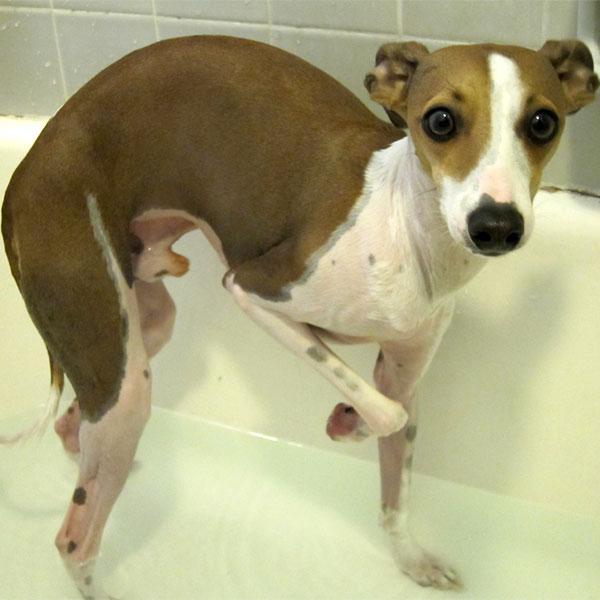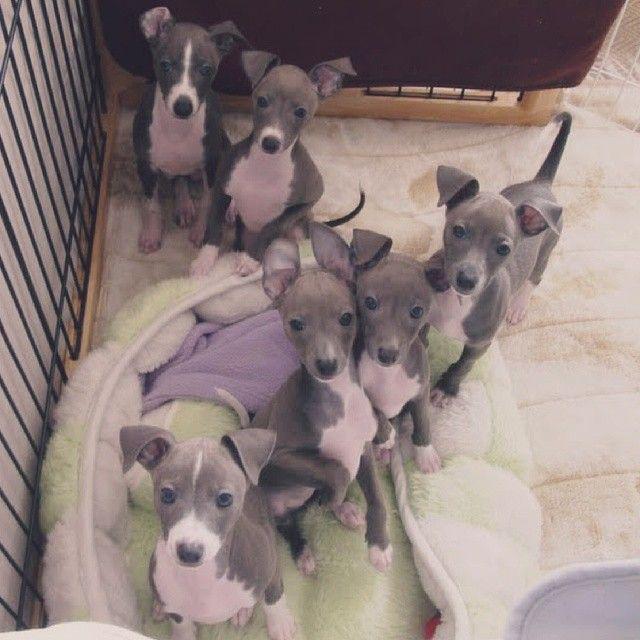The first image is the image on the left, the second image is the image on the right. Examine the images to the left and right. Is the description "One image contains only one dog, while the other image contains at least 5 dogs." accurate? Answer yes or no. Yes. The first image is the image on the left, the second image is the image on the right. Assess this claim about the two images: "There are more dogs in the right image than in the left.". Correct or not? Answer yes or no. Yes. The first image is the image on the left, the second image is the image on the right. Assess this claim about the two images: "One image contains a single dog, which is looking at the camera while in a standing pose indoors.". Correct or not? Answer yes or no. Yes. 